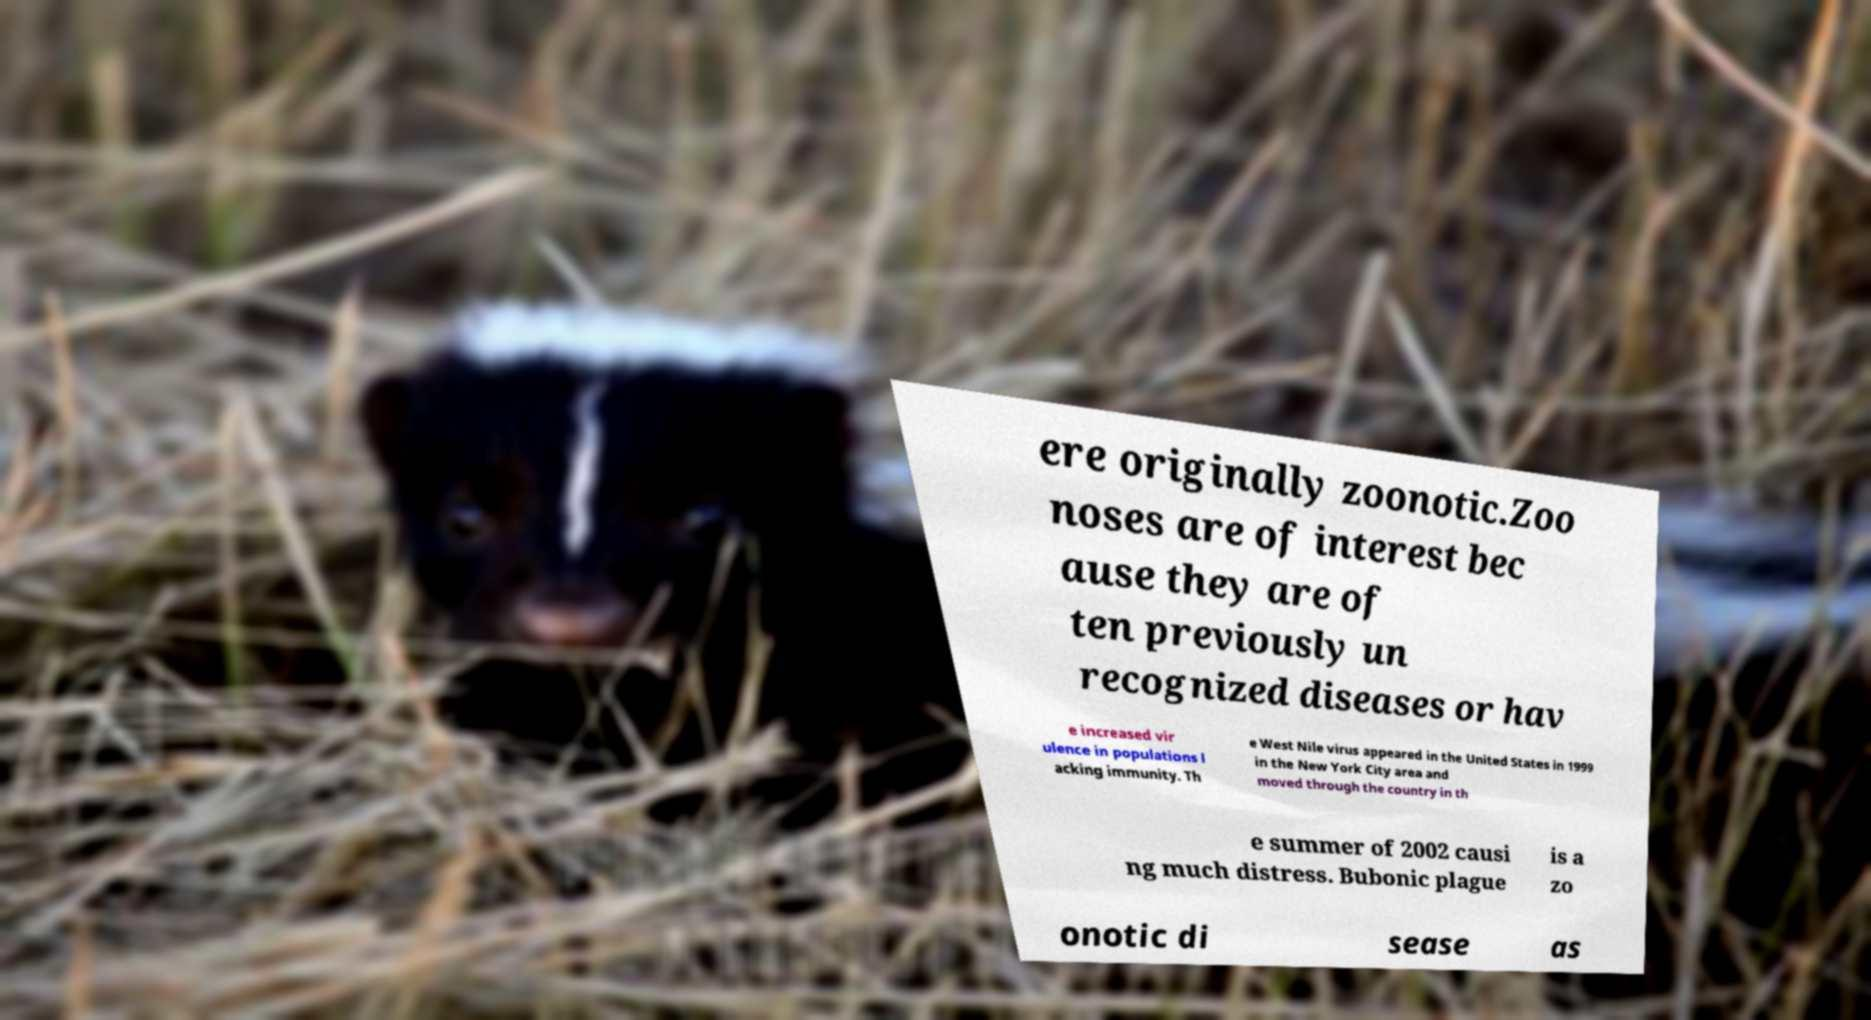I need the written content from this picture converted into text. Can you do that? ere originally zoonotic.Zoo noses are of interest bec ause they are of ten previously un recognized diseases or hav e increased vir ulence in populations l acking immunity. Th e West Nile virus appeared in the United States in 1999 in the New York City area and moved through the country in th e summer of 2002 causi ng much distress. Bubonic plague is a zo onotic di sease as 